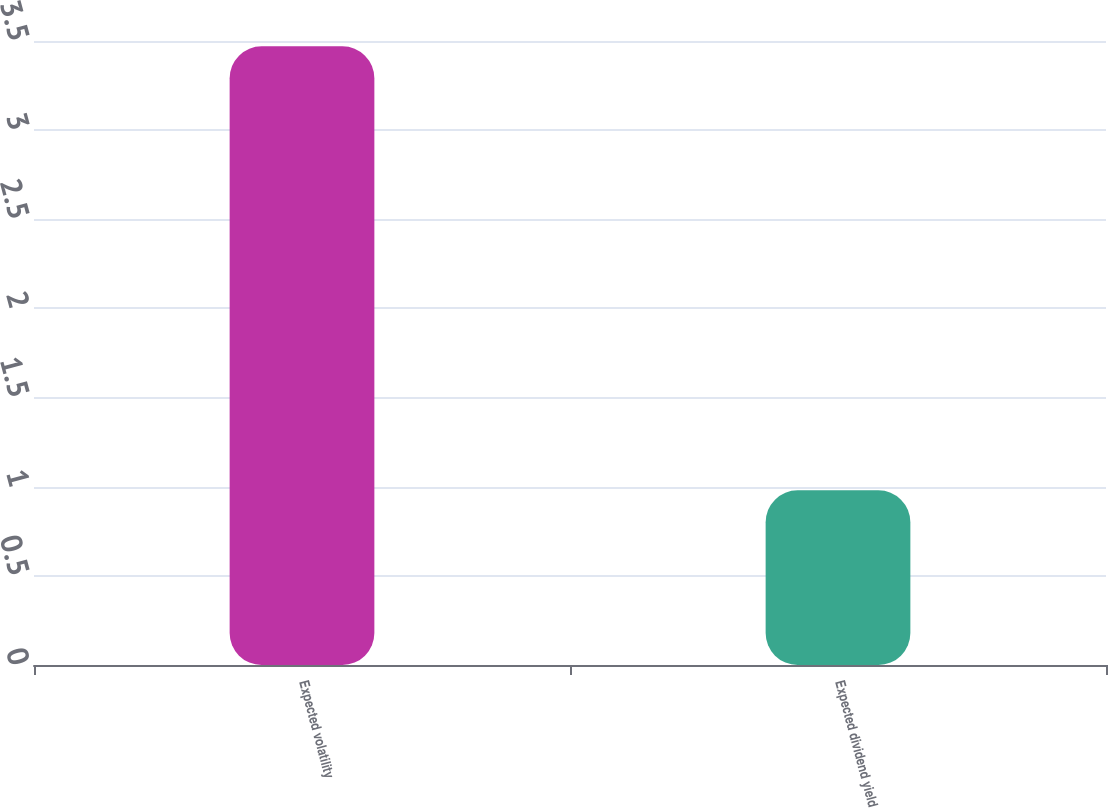Convert chart. <chart><loc_0><loc_0><loc_500><loc_500><bar_chart><fcel>Expected volatility<fcel>Expected dividend yield<nl><fcel>3.47<fcel>0.98<nl></chart> 